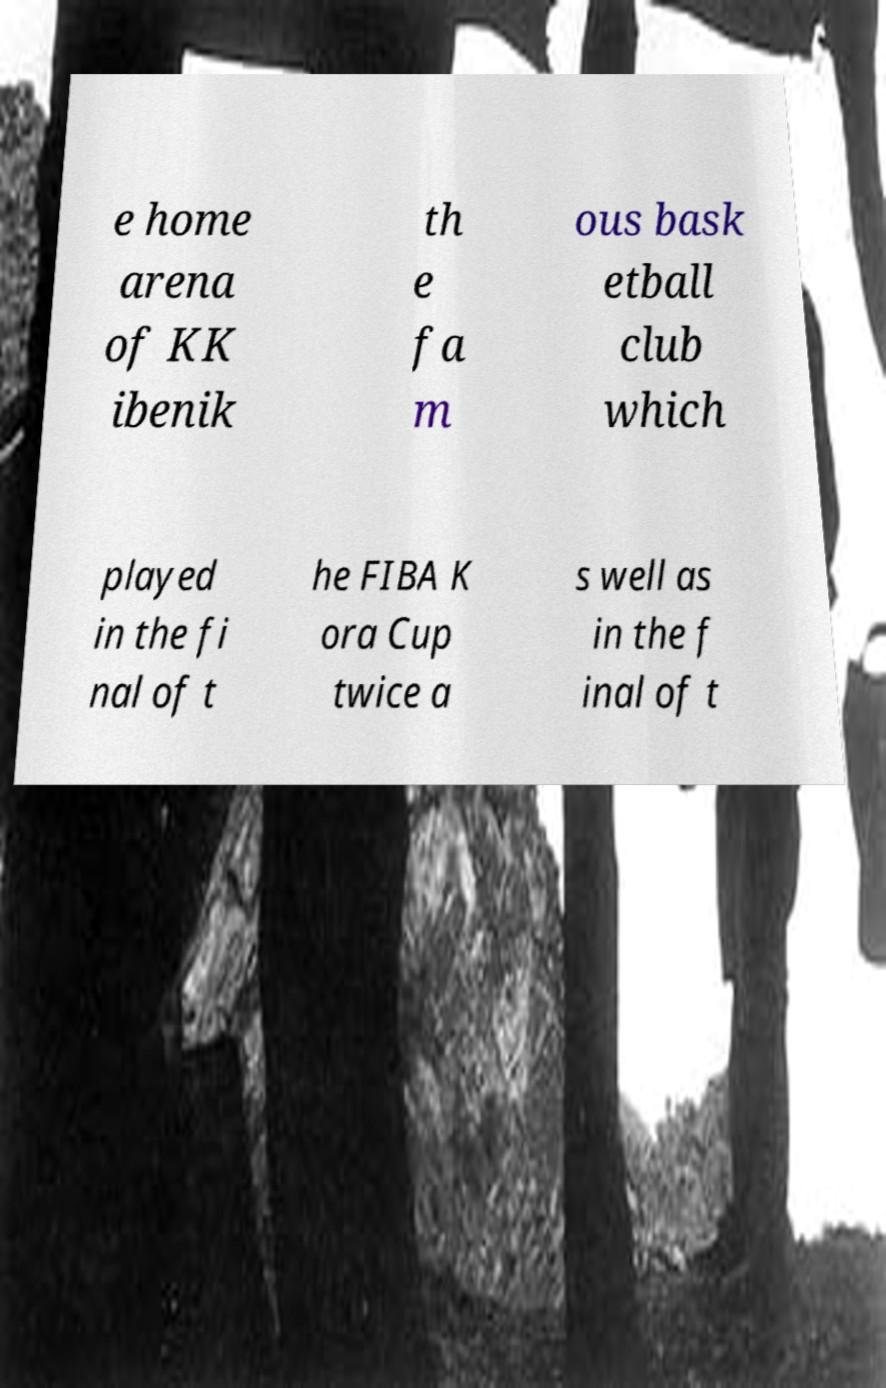I need the written content from this picture converted into text. Can you do that? e home arena of KK ibenik th e fa m ous bask etball club which played in the fi nal of t he FIBA K ora Cup twice a s well as in the f inal of t 